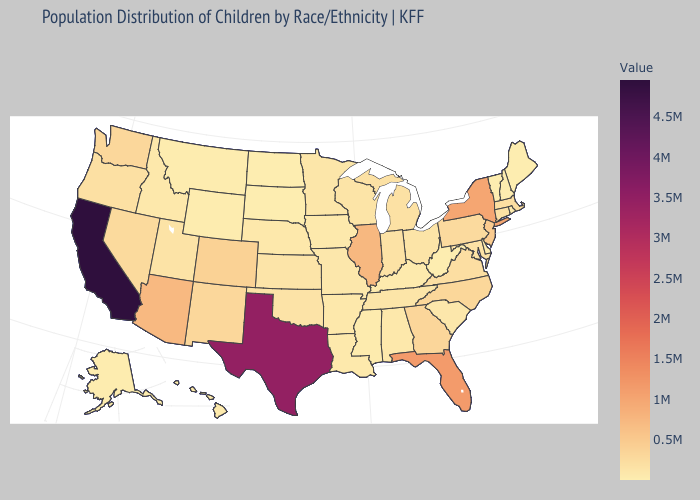Which states hav the highest value in the Northeast?
Be succinct. New York. Among the states that border Oklahoma , does Texas have the highest value?
Concise answer only. Yes. Which states hav the highest value in the South?
Quick response, please. Texas. Does Massachusetts have a higher value than Texas?
Keep it brief. No. Does the map have missing data?
Be succinct. No. Does Vermont have the lowest value in the Northeast?
Answer briefly. Yes. Which states have the lowest value in the Northeast?
Be succinct. Vermont. 